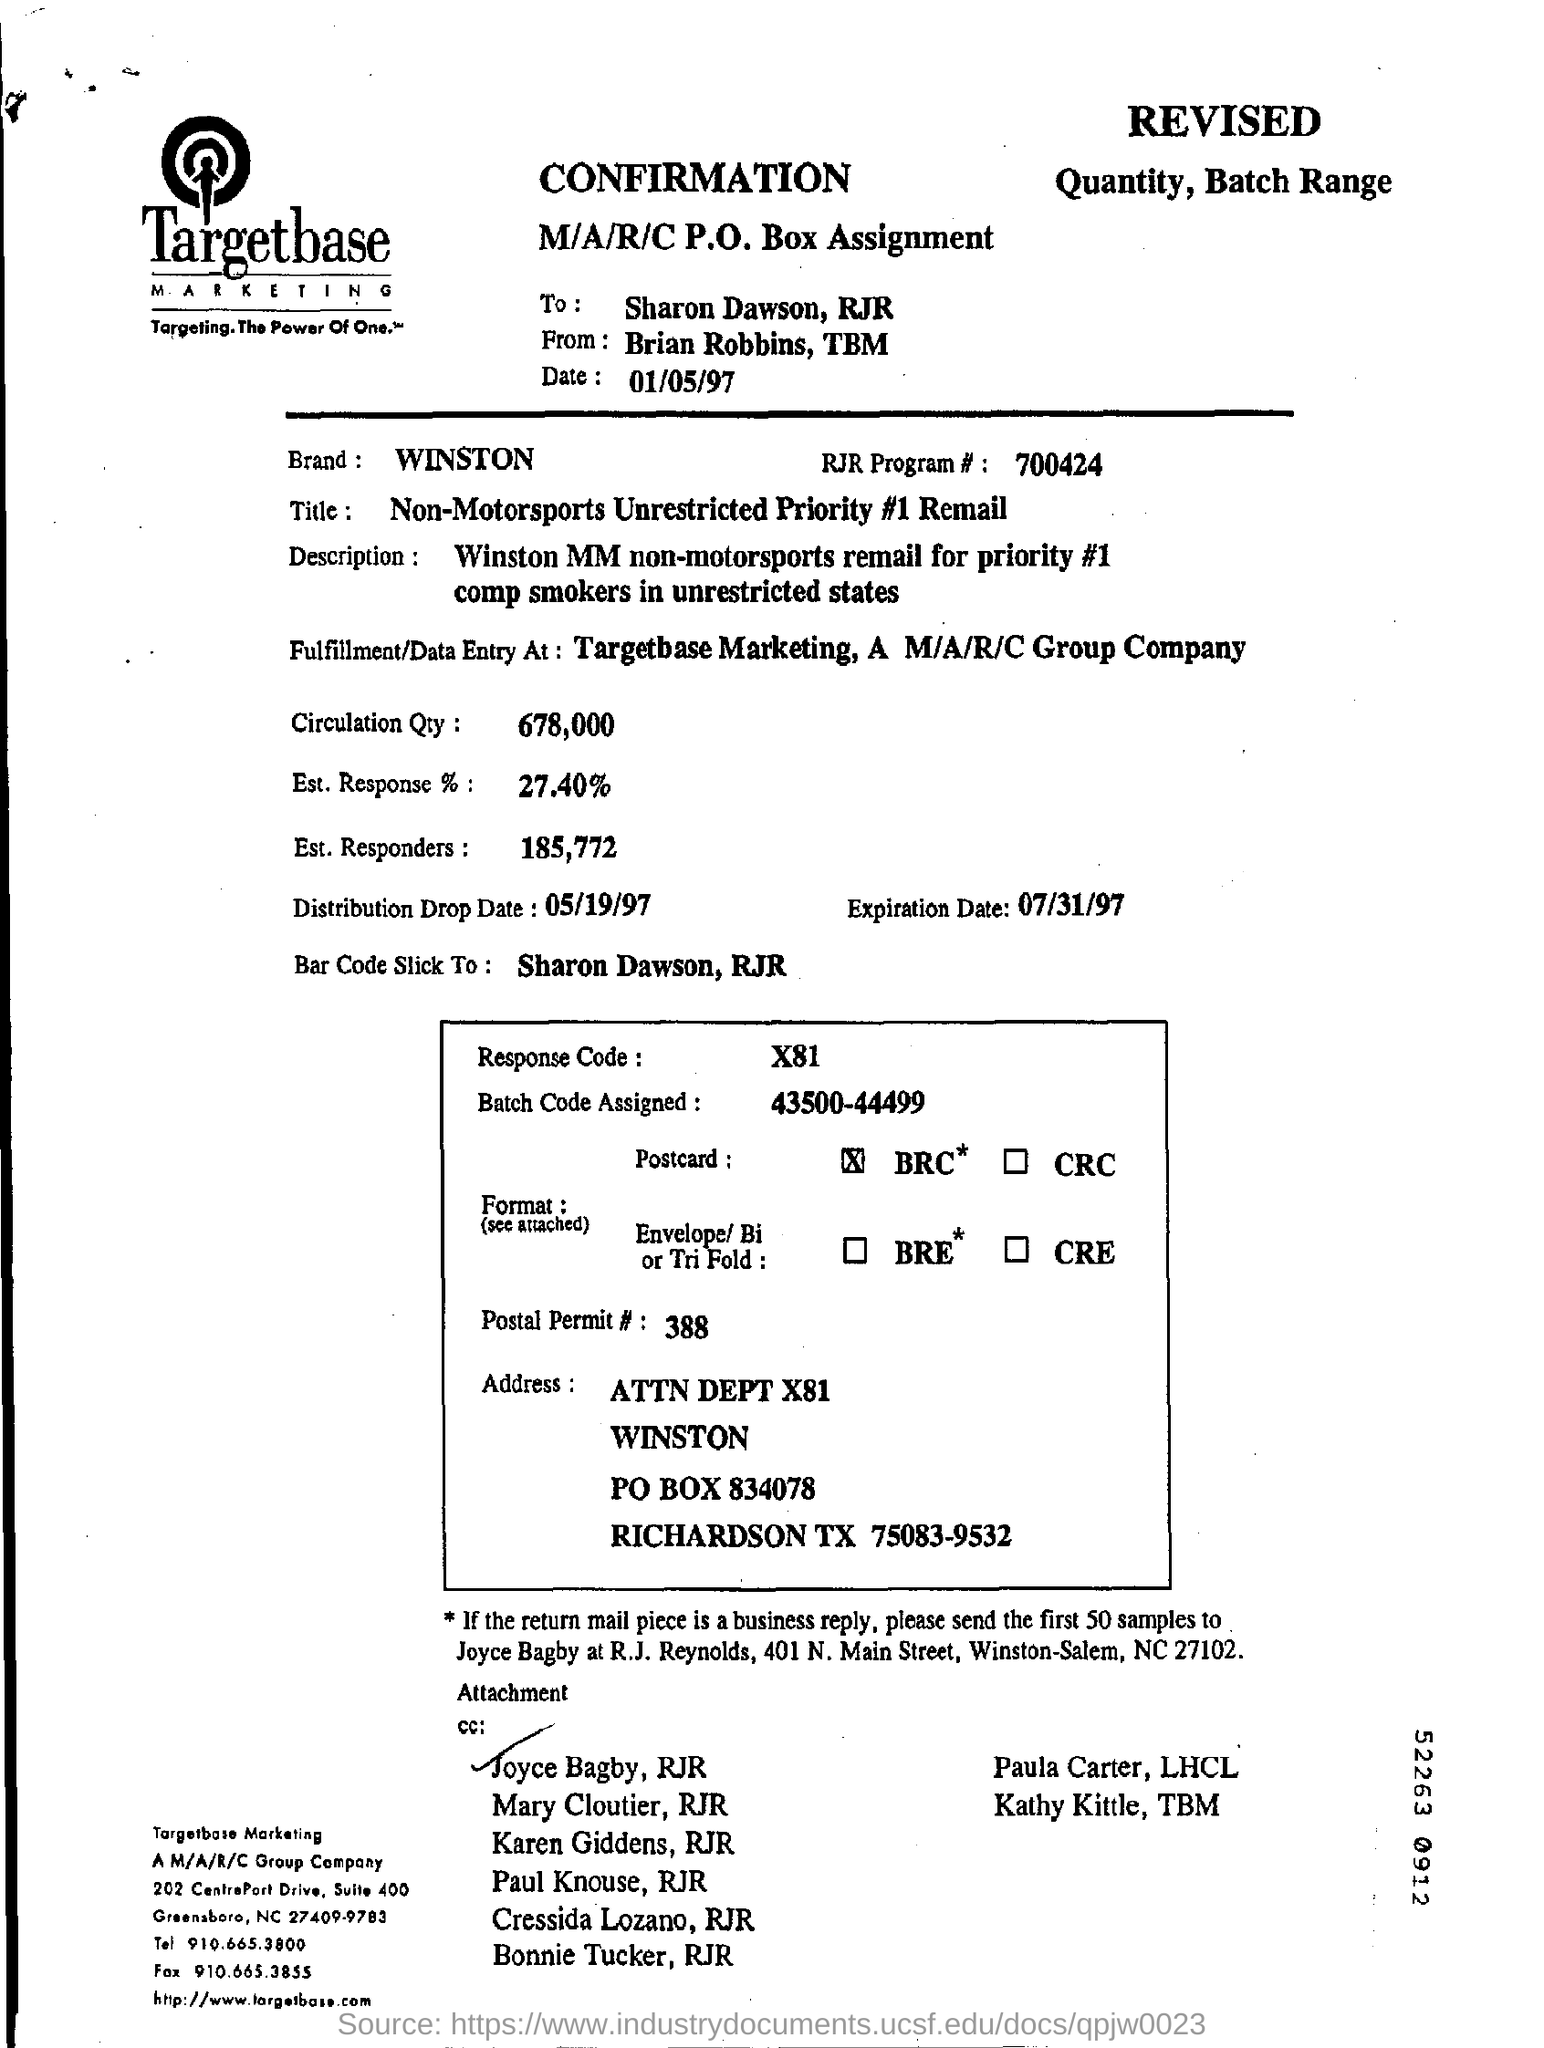What is the date written in this letter?
Your answer should be very brief. 01/05/97. What is the batch code assigned?
Offer a terse response. 43500-44499. What is the distribution drop date?
Ensure brevity in your answer.  05/19/97. What is the brand mentioned in the given document?
Provide a succinct answer. WINSTON. 